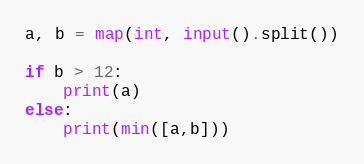Convert code to text. <code><loc_0><loc_0><loc_500><loc_500><_Python_>a, b = map(int, input().split())

if b > 12:
    print(a)
else:
    print(min([a,b]))

</code> 